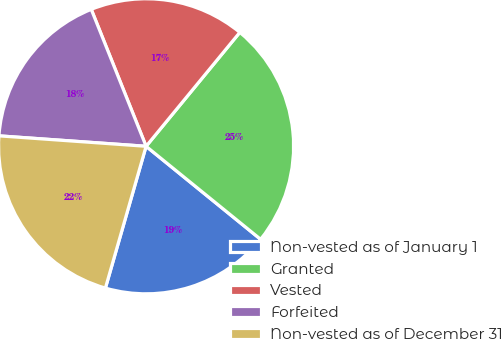Convert chart. <chart><loc_0><loc_0><loc_500><loc_500><pie_chart><fcel>Non-vested as of January 1<fcel>Granted<fcel>Vested<fcel>Forfeited<fcel>Non-vested as of December 31<nl><fcel>18.59%<fcel>24.9%<fcel>17.02%<fcel>17.81%<fcel>21.68%<nl></chart> 